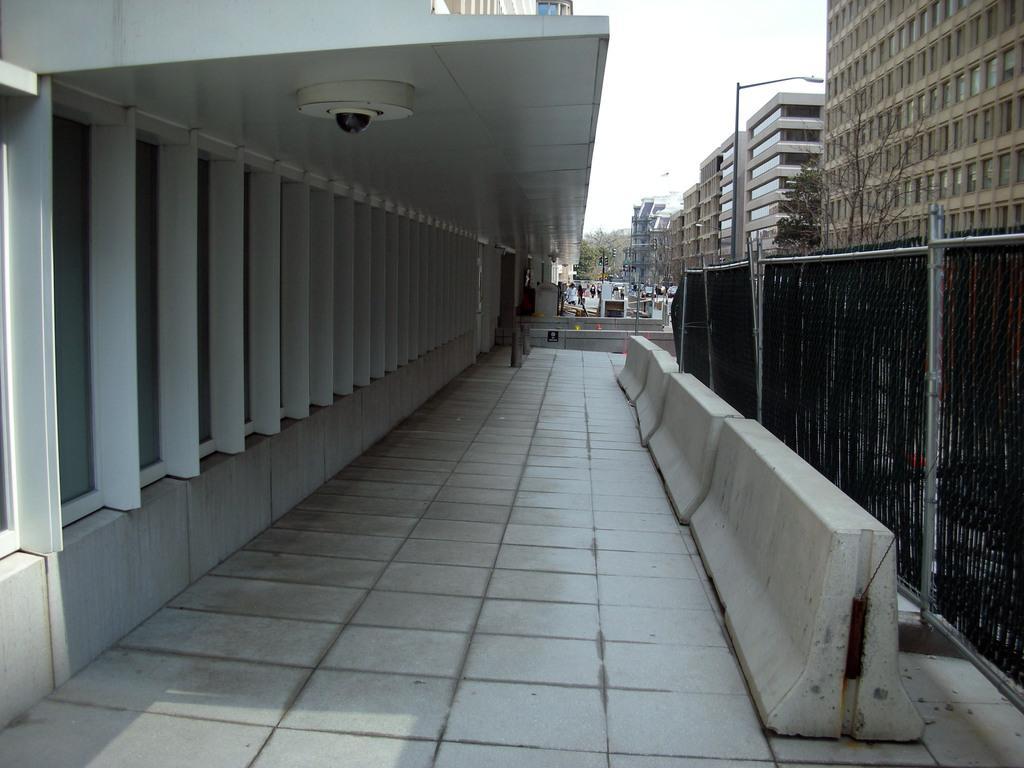Could you give a brief overview of what you see in this image? In the picture I can see buildings, a camera on the ceiling, fence, trees, street lights and some other objects on the ground. In the background I can see the sky. 